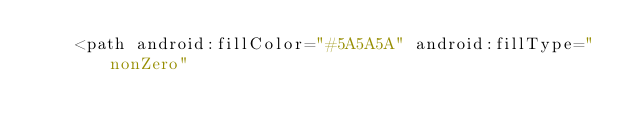<code> <loc_0><loc_0><loc_500><loc_500><_XML_>    <path android:fillColor="#5A5A5A" android:fillType="nonZero"</code> 